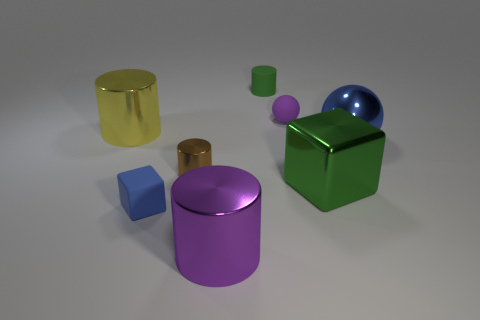Subtract all purple metal cylinders. How many cylinders are left? 3 Add 1 large blue rubber things. How many objects exist? 9 Subtract all brown cylinders. How many cylinders are left? 3 Subtract 1 cylinders. How many cylinders are left? 3 Subtract all blocks. How many objects are left? 6 Add 7 small metal balls. How many small metal balls exist? 7 Subtract 0 green balls. How many objects are left? 8 Subtract all brown blocks. Subtract all cyan cylinders. How many blocks are left? 2 Subtract all small purple matte balls. Subtract all big purple cylinders. How many objects are left? 6 Add 8 small matte blocks. How many small matte blocks are left? 9 